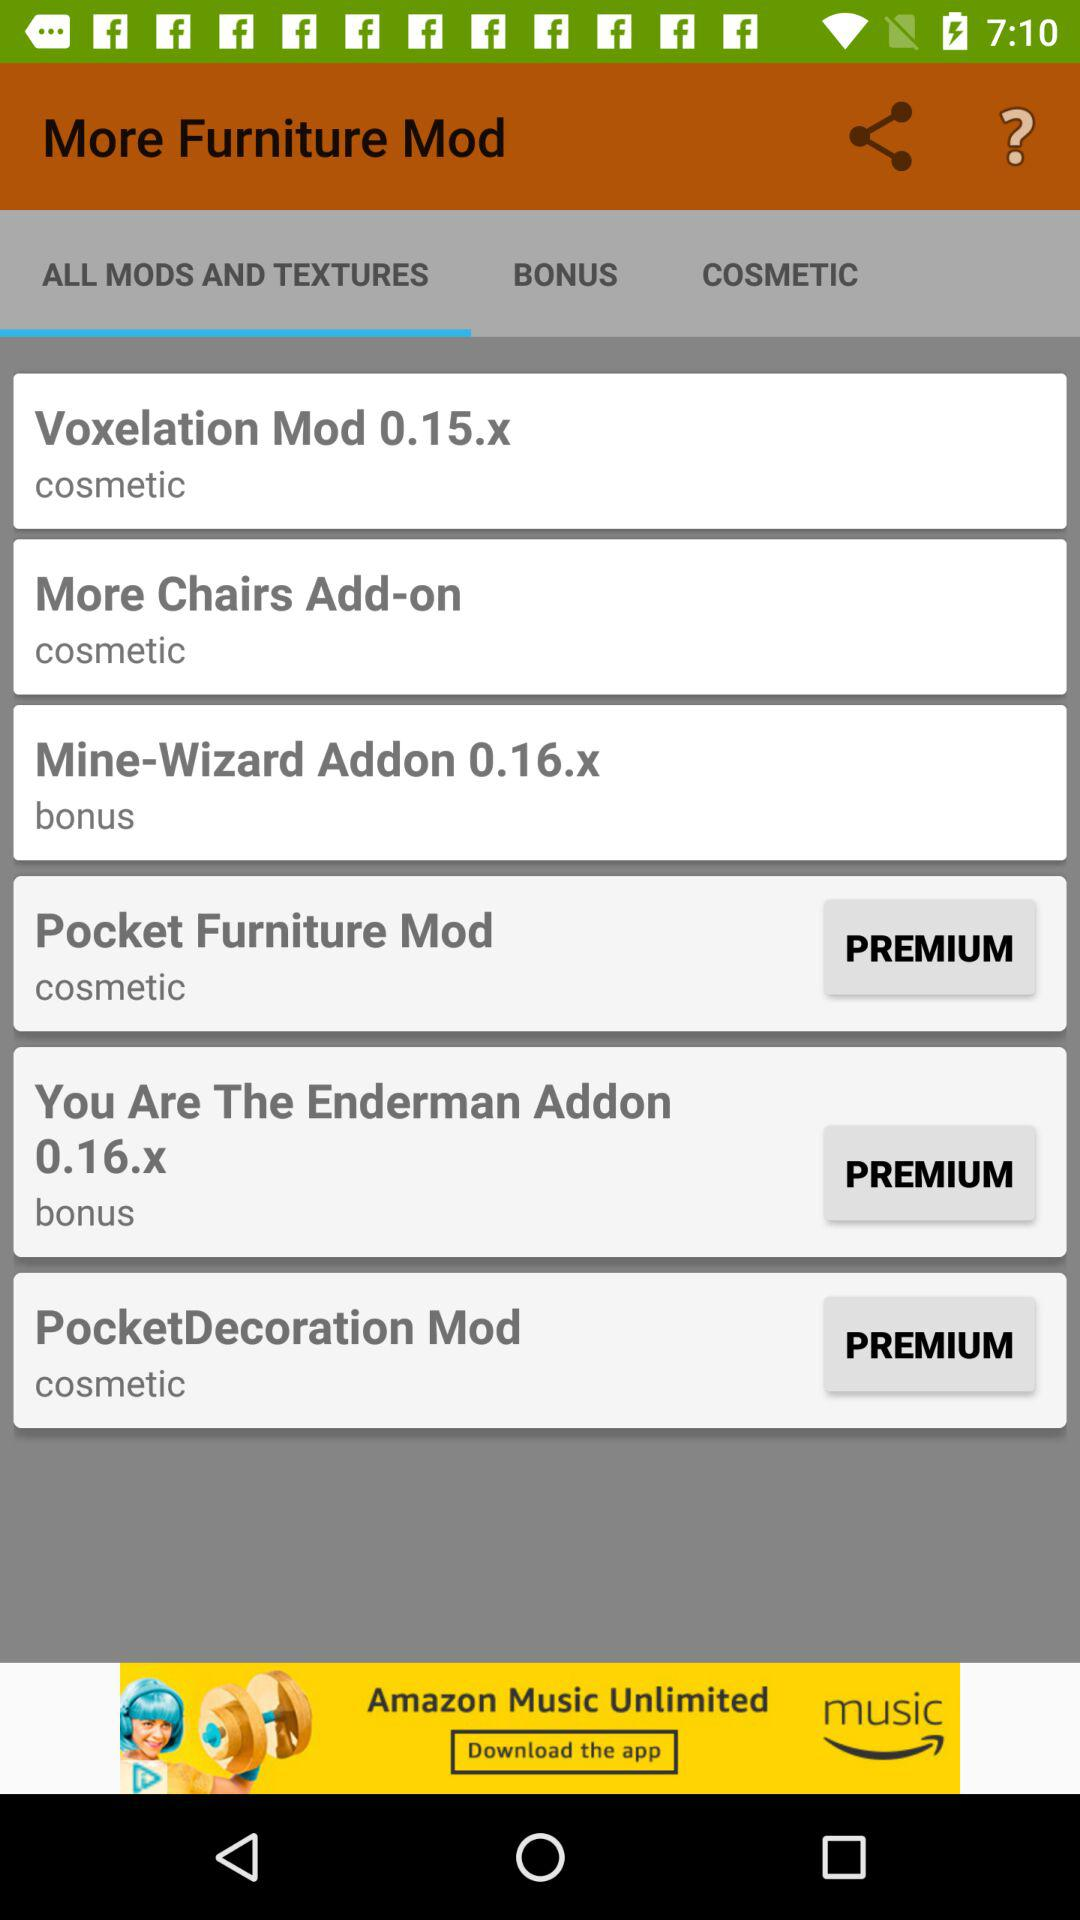How many premium mods are there?
Answer the question using a single word or phrase. 3 